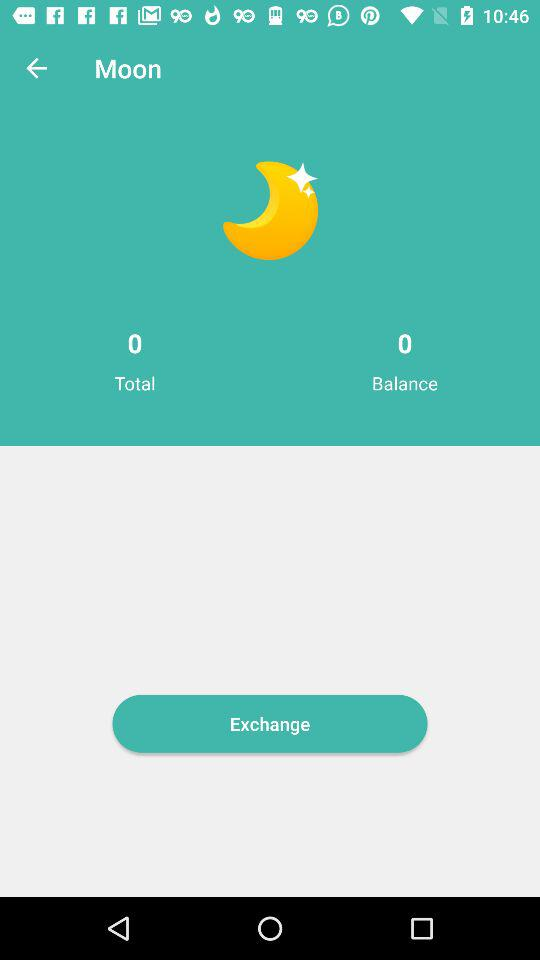What is the balance? The balance is 0. 